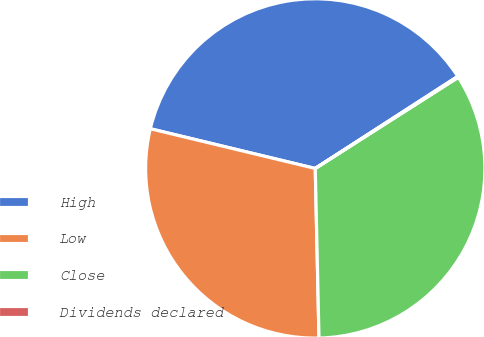<chart> <loc_0><loc_0><loc_500><loc_500><pie_chart><fcel>High<fcel>Low<fcel>Close<fcel>Dividends declared<nl><fcel>37.11%<fcel>29.11%<fcel>33.68%<fcel>0.1%<nl></chart> 